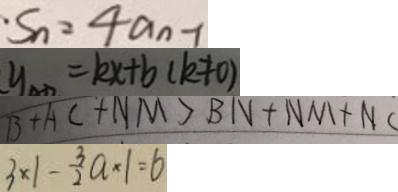Convert formula to latex. <formula><loc_0><loc_0><loc_500><loc_500>S _ { n } = 4 a _ { n } - 1 
 y = k x + b ( k \neq 0 ) 
 B + A C + N M > B N + N M + N C 
 3 \times 1 - \frac { 3 } { 2 } a \times 1 = 6</formula> 